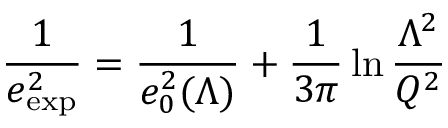Convert formula to latex. <formula><loc_0><loc_0><loc_500><loc_500>{ \frac { 1 } { e _ { e x p } ^ { 2 } } } = { \frac { 1 } { e _ { 0 } ^ { 2 } ( \Lambda ) } } + { \frac { 1 } { 3 \pi } } \ln { \frac { \Lambda ^ { 2 } } { Q ^ { 2 } } }</formula> 